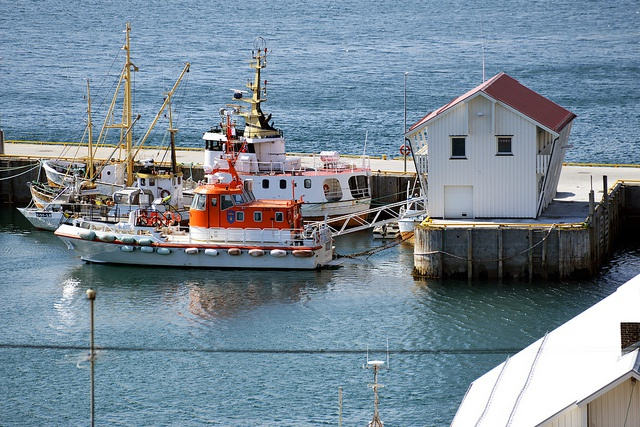Describe the objects in this image and their specific colors. I can see boat in gray, black, darkgray, and lightgray tones, boat in gray, darkgray, and black tones, boat in gray, darkgray, black, and lightgray tones, and boat in gray, darkgray, and black tones in this image. 